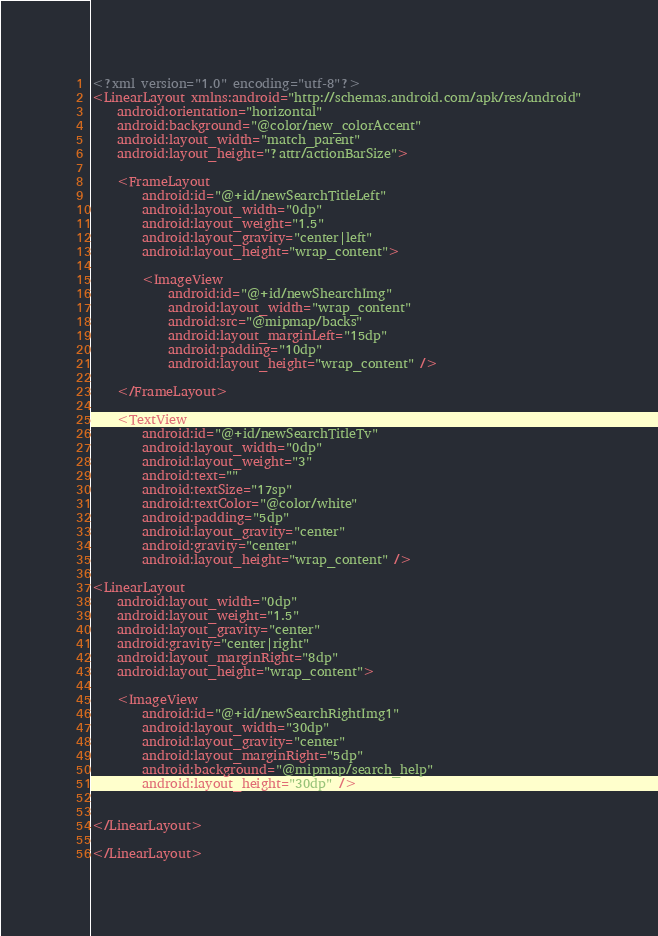<code> <loc_0><loc_0><loc_500><loc_500><_XML_><?xml version="1.0" encoding="utf-8"?>
<LinearLayout xmlns:android="http://schemas.android.com/apk/res/android"
    android:orientation="horizontal"
    android:background="@color/new_colorAccent"
    android:layout_width="match_parent"
    android:layout_height="?attr/actionBarSize">

    <FrameLayout
        android:id="@+id/newSearchTitleLeft"
        android:layout_width="0dp"
        android:layout_weight="1.5"
        android:layout_gravity="center|left"
        android:layout_height="wrap_content">

        <ImageView
            android:id="@+id/newShearchImg"
            android:layout_width="wrap_content"
            android:src="@mipmap/backs"
            android:layout_marginLeft="15dp"
            android:padding="10dp"
            android:layout_height="wrap_content" />

    </FrameLayout>

    <TextView
        android:id="@+id/newSearchTitleTv"
        android:layout_width="0dp"
        android:layout_weight="3"
        android:text=""
        android:textSize="17sp"
        android:textColor="@color/white"
        android:padding="5dp"
        android:layout_gravity="center"
        android:gravity="center"
        android:layout_height="wrap_content" />

<LinearLayout
    android:layout_width="0dp"
    android:layout_weight="1.5"
    android:layout_gravity="center"
    android:gravity="center|right"
    android:layout_marginRight="8dp"
    android:layout_height="wrap_content">

    <ImageView
        android:id="@+id/newSearchRightImg1"
        android:layout_width="30dp"
        android:layout_gravity="center"
        android:layout_marginRight="5dp"
        android:background="@mipmap/search_help"
        android:layout_height="30dp" />


</LinearLayout>

</LinearLayout></code> 